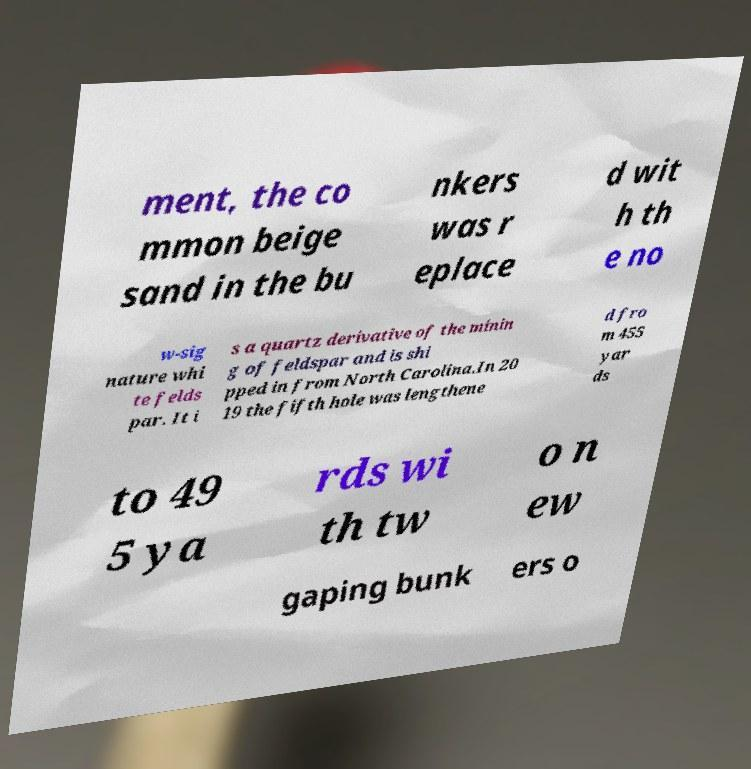Could you assist in decoding the text presented in this image and type it out clearly? ment, the co mmon beige sand in the bu nkers was r eplace d wit h th e no w-sig nature whi te felds par. It i s a quartz derivative of the minin g of feldspar and is shi pped in from North Carolina.In 20 19 the fifth hole was lengthene d fro m 455 yar ds to 49 5 ya rds wi th tw o n ew gaping bunk ers o 